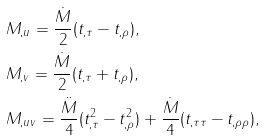<formula> <loc_0><loc_0><loc_500><loc_500>& M _ { , u } = \frac { \dot { M } } { 2 } ( t _ { , \tau } - t _ { , \rho } ) , \\ & M _ { , v } = \frac { \dot { M } } { 2 } ( t _ { , \tau } + t _ { , \rho } ) , \\ & M _ { , u v } = \frac { \ddot { M } } { 4 } ( t _ { , \tau } ^ { 2 } - t _ { , \rho } ^ { 2 } ) + \frac { \dot { M } } { 4 } ( t _ { , \tau \tau } - t _ { , \rho \rho } ) ,</formula> 